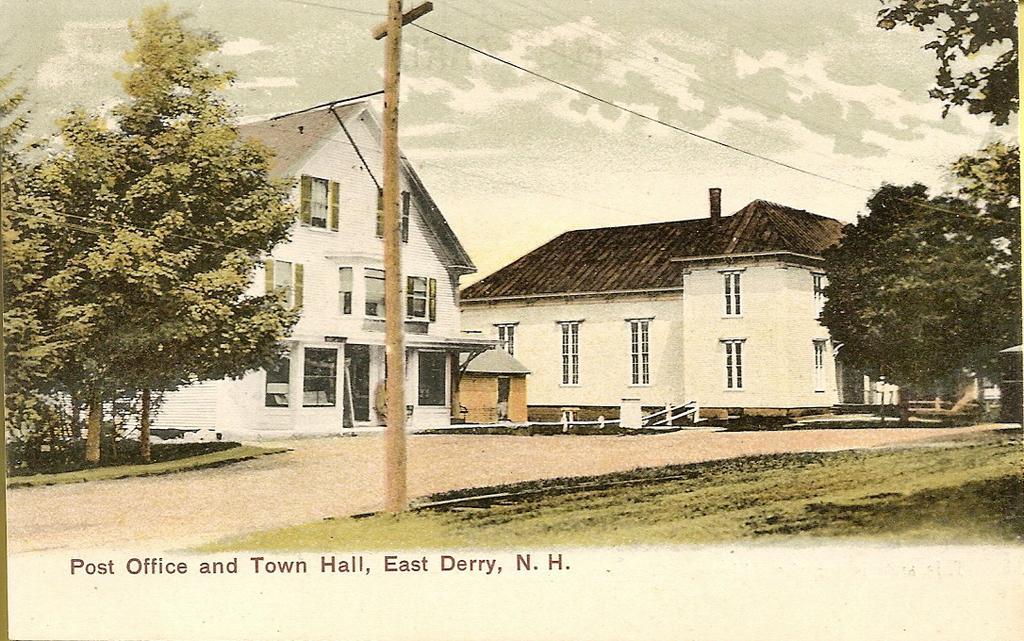Describe this image in one or two sentences. In the image we can see the poster, in the poster we can see the buildings and these are the windows of the buildings. We can even see there are trees, grass, electric pole, electric and 